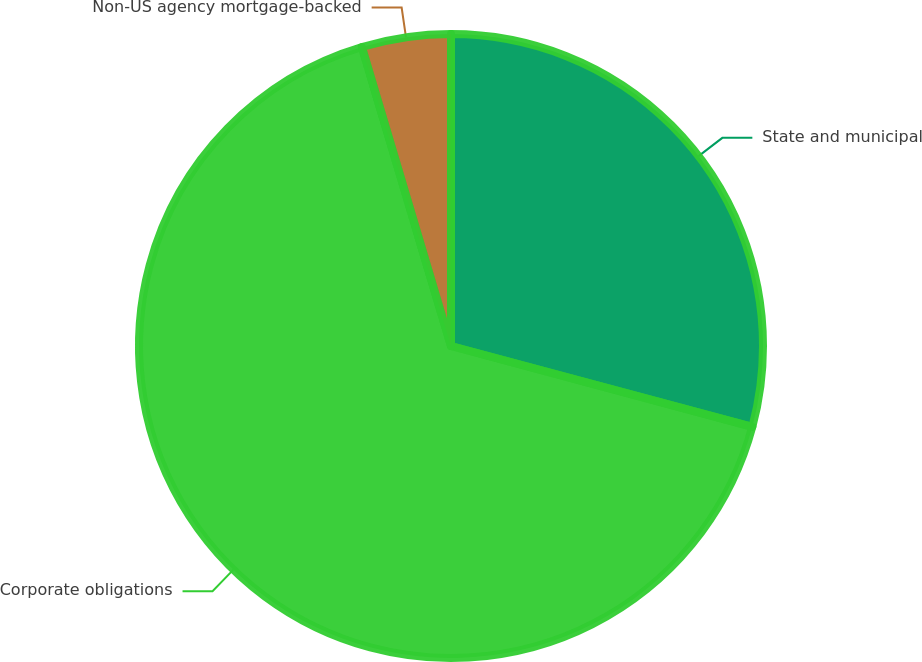Convert chart. <chart><loc_0><loc_0><loc_500><loc_500><pie_chart><fcel>State and municipal<fcel>Corporate obligations<fcel>Non-US agency mortgage-backed<nl><fcel>29.17%<fcel>66.22%<fcel>4.61%<nl></chart> 